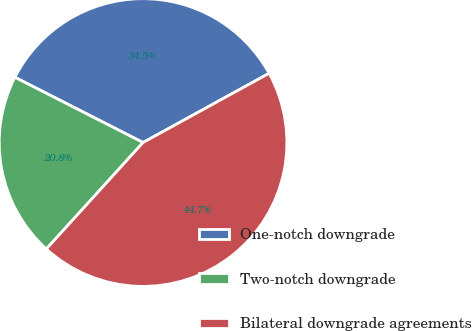Convert chart to OTSL. <chart><loc_0><loc_0><loc_500><loc_500><pie_chart><fcel>One-notch downgrade<fcel>Two-notch downgrade<fcel>Bilateral downgrade agreements<nl><fcel>34.51%<fcel>20.76%<fcel>44.73%<nl></chart> 